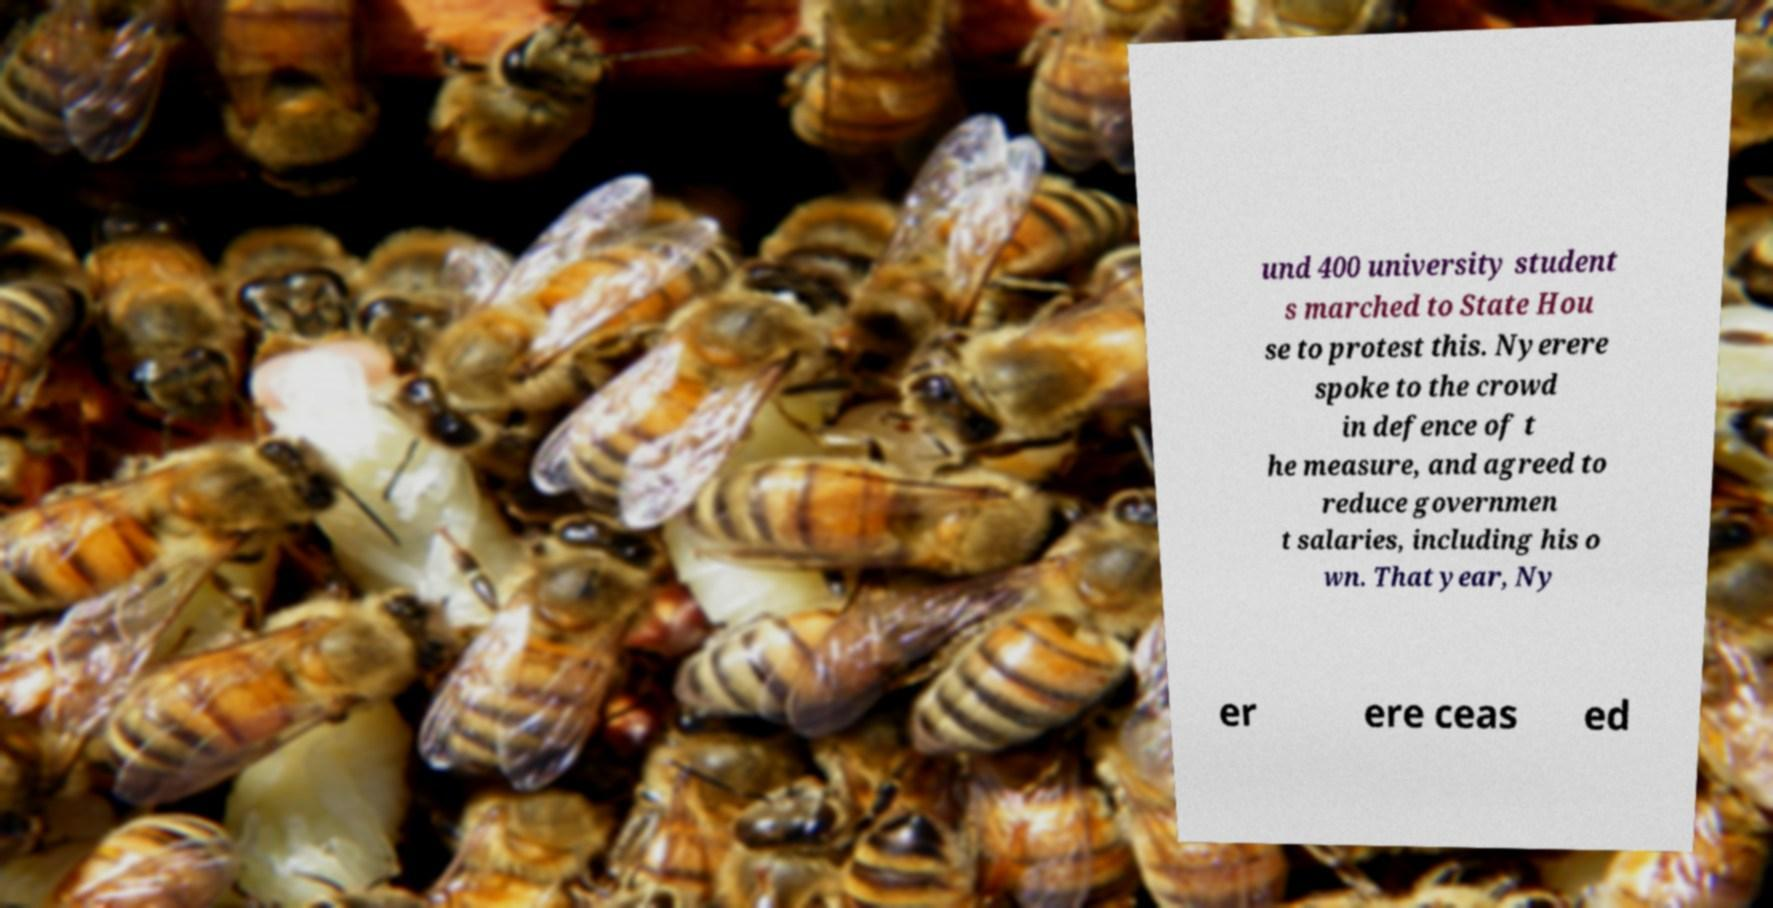Could you extract and type out the text from this image? und 400 university student s marched to State Hou se to protest this. Nyerere spoke to the crowd in defence of t he measure, and agreed to reduce governmen t salaries, including his o wn. That year, Ny er ere ceas ed 